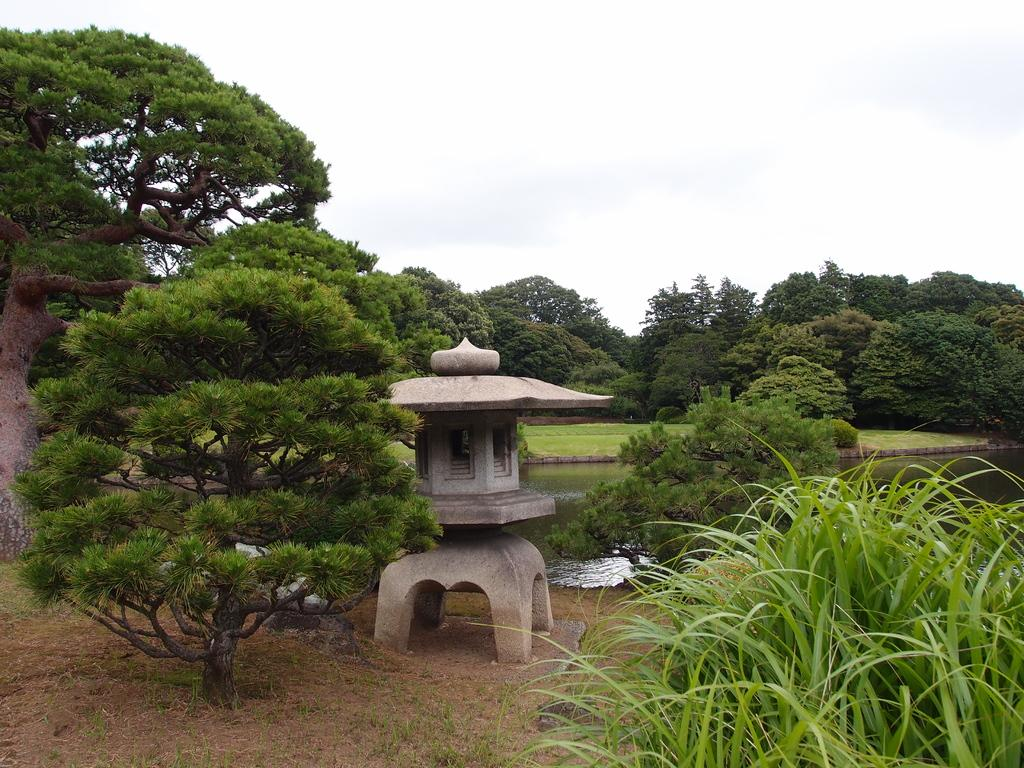What type of vegetation can be seen in the image? There are trees and plants in the image. What natural element is visible in the image? There is water visible in the image. What is the main structure in the middle of the image? There is a small house-like structure in the middle of the image. How would you describe the sky in the image? The sky is cloudy in the image. What type of art can be seen hanging on the trees in the image? There is no art visible hanging on the trees in the image. How does the weather affect the small house-like structure in the image? The provided facts do not mention any weather conditions affecting the small house-like structure, so we cannot answer this question. 